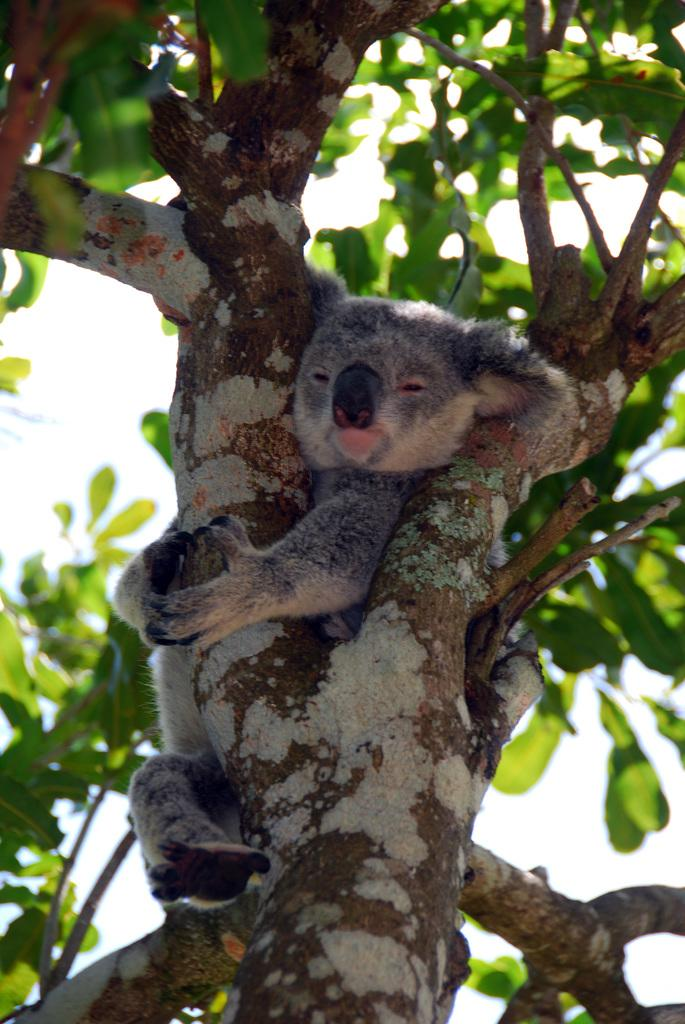Where was the image taken? The image is taken outdoors. What can be seen in the image besides the outdoor setting? There is a tree with green leaves, branches, and stems in the image. Is there any wildlife present in the image? Yes, a koala is present on the tree in the image. What type of alley can be seen in the image? There is no alley present in the image; it is taken outdoors with a tree and a koala. What color are the bricks on the tree in the image? The tree in the image is a natural structure and does not have bricks; it has green leaves, branches, and stems. 